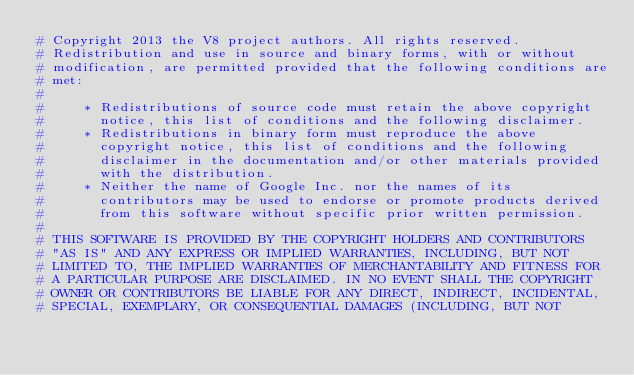Convert code to text. <code><loc_0><loc_0><loc_500><loc_500><_Python_># Copyright 2013 the V8 project authors. All rights reserved.
# Redistribution and use in source and binary forms, with or without
# modification, are permitted provided that the following conditions are
# met:
#
#     * Redistributions of source code must retain the above copyright
#       notice, this list of conditions and the following disclaimer.
#     * Redistributions in binary form must reproduce the above
#       copyright notice, this list of conditions and the following
#       disclaimer in the documentation and/or other materials provided
#       with the distribution.
#     * Neither the name of Google Inc. nor the names of its
#       contributors may be used to endorse or promote products derived
#       from this software without specific prior written permission.
#
# THIS SOFTWARE IS PROVIDED BY THE COPYRIGHT HOLDERS AND CONTRIBUTORS
# "AS IS" AND ANY EXPRESS OR IMPLIED WARRANTIES, INCLUDING, BUT NOT
# LIMITED TO, THE IMPLIED WARRANTIES OF MERCHANTABILITY AND FITNESS FOR
# A PARTICULAR PURPOSE ARE DISCLAIMED. IN NO EVENT SHALL THE COPYRIGHT
# OWNER OR CONTRIBUTORS BE LIABLE FOR ANY DIRECT, INDIRECT, INCIDENTAL,
# SPECIAL, EXEMPLARY, OR CONSEQUENTIAL DAMAGES (INCLUDING, BUT NOT</code> 